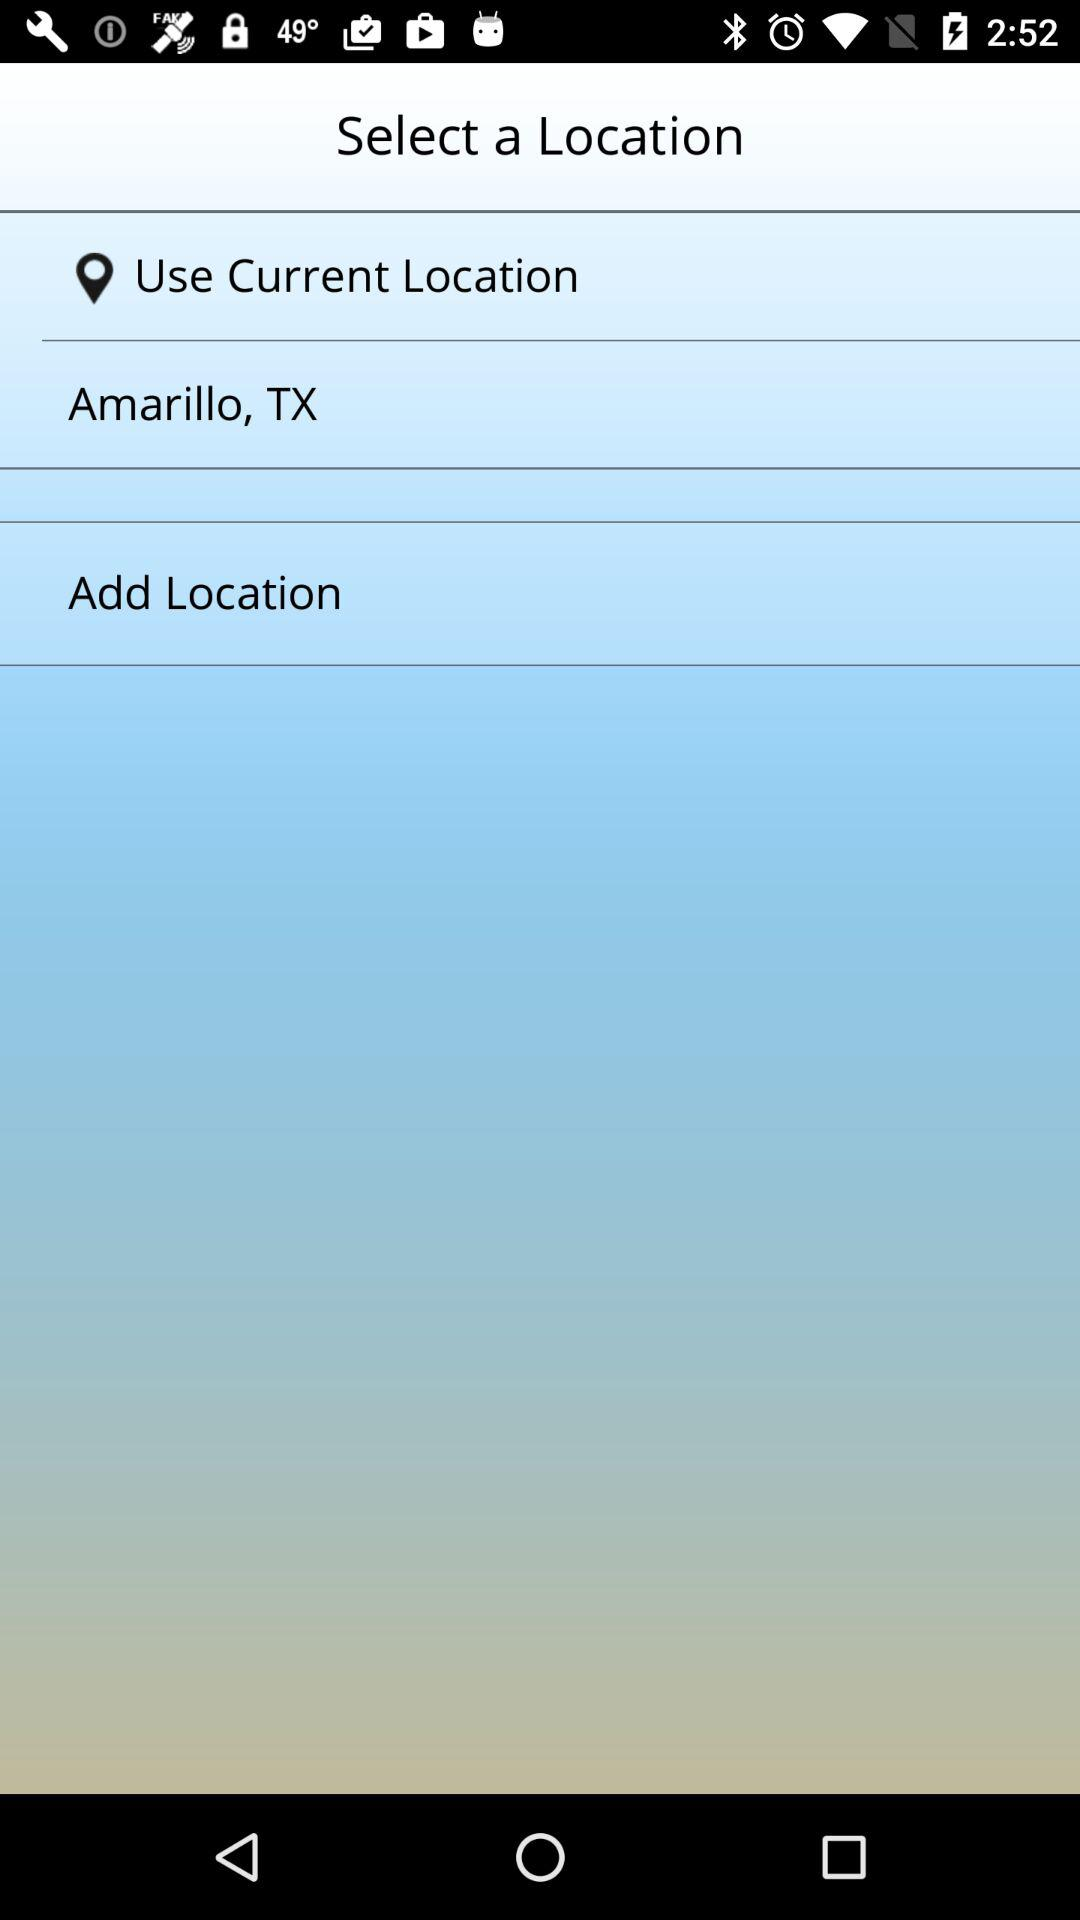What is the mentioned location? The mentioned location is Amarillo, TX. 